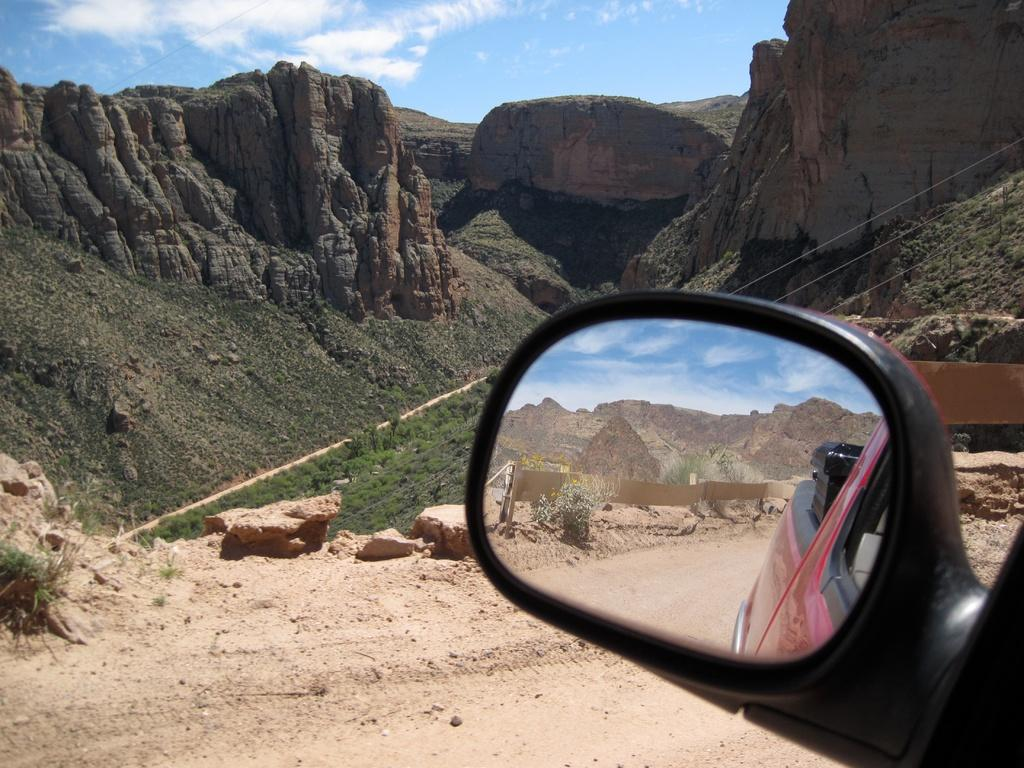What is the source of the reflection in the image? The reflection in the image is from a car's side view mirror. What can be seen in the distance in the image? Mountains are visible in the background of the image. How does the car's side view mirror aid in the digestion process in the image? The car's side view mirror does not aid in the digestion process in the image, as it is a reflection from a car and not related to digestion. 